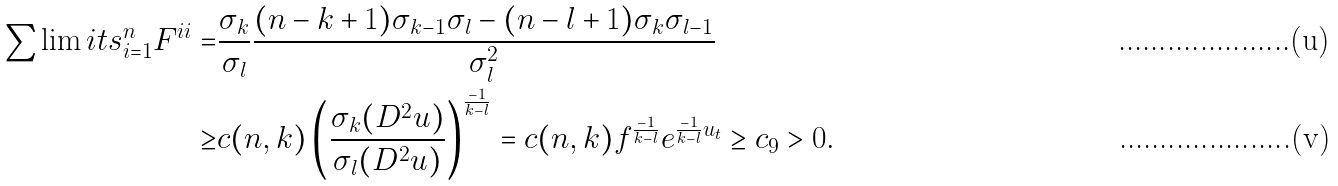Convert formula to latex. <formula><loc_0><loc_0><loc_500><loc_500>\sum \lim i t s _ { i = 1 } ^ { n } { F ^ { i i } } = & \frac { \sigma _ { k } } { \sigma _ { l } } \frac { { ( n - k + 1 ) \sigma _ { k - 1 } \sigma _ { l } - ( n - l + 1 ) \sigma _ { k } \sigma _ { l - 1 } } } { \sigma _ { l } ^ { 2 } } \\ \geq & c ( n , k ) \left ( \frac { \sigma _ { k } ( D ^ { 2 } u ) } { \sigma _ { l } ( D ^ { 2 } u ) } \right ) ^ { \frac { - 1 } { k - l } } = c ( { n , k } ) f ^ { \frac { - 1 } { k - l } } e ^ { \frac { - 1 } { k - l } u _ { t } } \geq c _ { 9 } > 0 .</formula> 